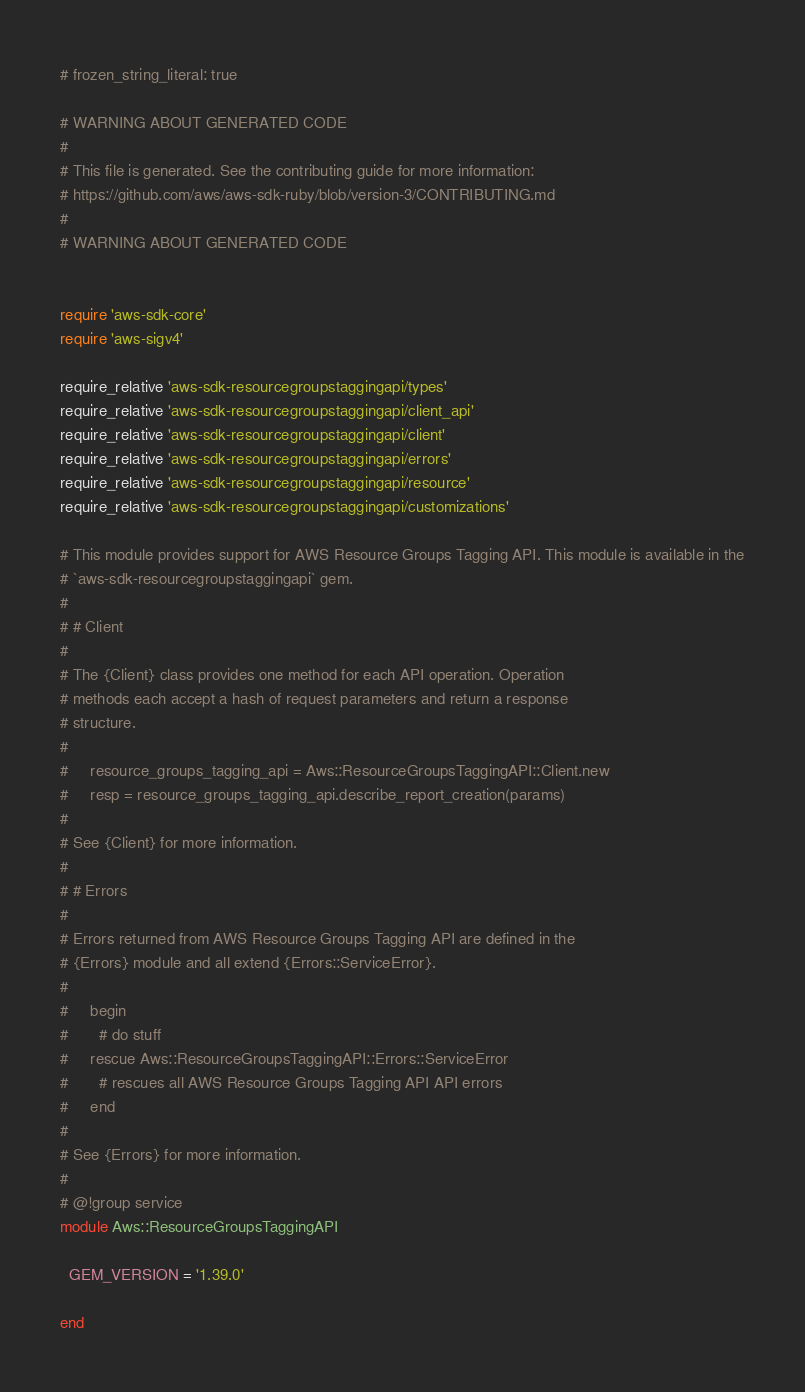<code> <loc_0><loc_0><loc_500><loc_500><_Ruby_># frozen_string_literal: true

# WARNING ABOUT GENERATED CODE
#
# This file is generated. See the contributing guide for more information:
# https://github.com/aws/aws-sdk-ruby/blob/version-3/CONTRIBUTING.md
#
# WARNING ABOUT GENERATED CODE


require 'aws-sdk-core'
require 'aws-sigv4'

require_relative 'aws-sdk-resourcegroupstaggingapi/types'
require_relative 'aws-sdk-resourcegroupstaggingapi/client_api'
require_relative 'aws-sdk-resourcegroupstaggingapi/client'
require_relative 'aws-sdk-resourcegroupstaggingapi/errors'
require_relative 'aws-sdk-resourcegroupstaggingapi/resource'
require_relative 'aws-sdk-resourcegroupstaggingapi/customizations'

# This module provides support for AWS Resource Groups Tagging API. This module is available in the
# `aws-sdk-resourcegroupstaggingapi` gem.
#
# # Client
#
# The {Client} class provides one method for each API operation. Operation
# methods each accept a hash of request parameters and return a response
# structure.
#
#     resource_groups_tagging_api = Aws::ResourceGroupsTaggingAPI::Client.new
#     resp = resource_groups_tagging_api.describe_report_creation(params)
#
# See {Client} for more information.
#
# # Errors
#
# Errors returned from AWS Resource Groups Tagging API are defined in the
# {Errors} module and all extend {Errors::ServiceError}.
#
#     begin
#       # do stuff
#     rescue Aws::ResourceGroupsTaggingAPI::Errors::ServiceError
#       # rescues all AWS Resource Groups Tagging API API errors
#     end
#
# See {Errors} for more information.
#
# @!group service
module Aws::ResourceGroupsTaggingAPI

  GEM_VERSION = '1.39.0'

end
</code> 